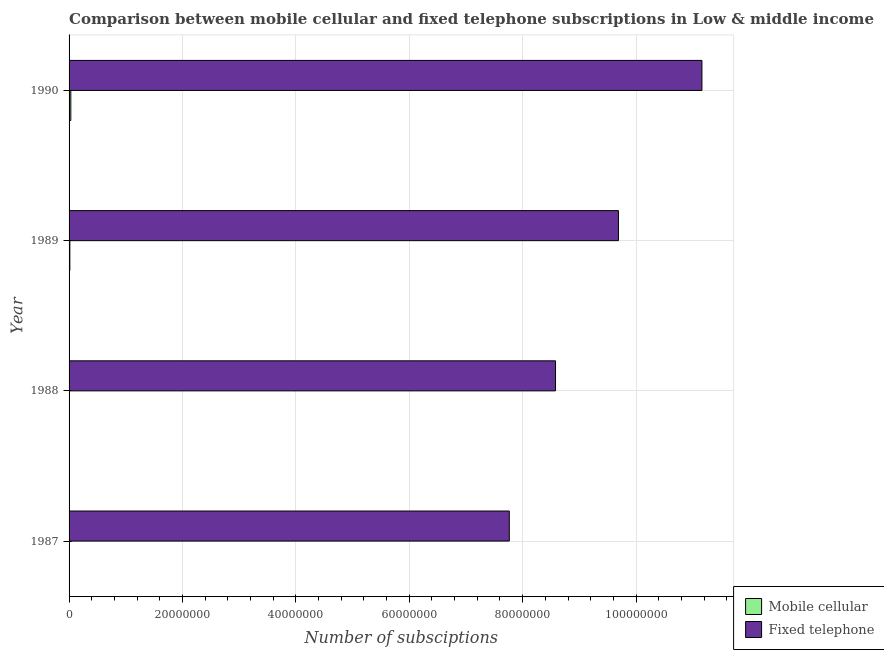How many different coloured bars are there?
Your response must be concise. 2. Are the number of bars per tick equal to the number of legend labels?
Keep it short and to the point. Yes. How many bars are there on the 4th tick from the top?
Keep it short and to the point. 2. In how many cases, is the number of bars for a given year not equal to the number of legend labels?
Provide a short and direct response. 0. What is the number of fixed telephone subscriptions in 1988?
Ensure brevity in your answer.  8.58e+07. Across all years, what is the maximum number of mobile cellular subscriptions?
Provide a short and direct response. 3.07e+05. Across all years, what is the minimum number of mobile cellular subscriptions?
Ensure brevity in your answer.  3.83e+04. In which year was the number of mobile cellular subscriptions maximum?
Provide a short and direct response. 1990. What is the total number of mobile cellular subscriptions in the graph?
Offer a very short reply. 5.52e+05. What is the difference between the number of fixed telephone subscriptions in 1987 and that in 1990?
Give a very brief answer. -3.40e+07. What is the difference between the number of fixed telephone subscriptions in 1987 and the number of mobile cellular subscriptions in 1988?
Give a very brief answer. 7.76e+07. What is the average number of mobile cellular subscriptions per year?
Give a very brief answer. 1.38e+05. In the year 1987, what is the difference between the number of fixed telephone subscriptions and number of mobile cellular subscriptions?
Ensure brevity in your answer.  7.76e+07. What is the ratio of the number of mobile cellular subscriptions in 1987 to that in 1989?
Provide a succinct answer. 0.28. What is the difference between the highest and the second highest number of fixed telephone subscriptions?
Make the answer very short. 1.47e+07. What is the difference between the highest and the lowest number of fixed telephone subscriptions?
Give a very brief answer. 3.40e+07. What does the 2nd bar from the top in 1988 represents?
Keep it short and to the point. Mobile cellular. What does the 1st bar from the bottom in 1987 represents?
Offer a terse response. Mobile cellular. Are the values on the major ticks of X-axis written in scientific E-notation?
Make the answer very short. No. Does the graph contain any zero values?
Provide a short and direct response. No. What is the title of the graph?
Offer a very short reply. Comparison between mobile cellular and fixed telephone subscriptions in Low & middle income. Does "constant 2005 US$" appear as one of the legend labels in the graph?
Provide a succinct answer. No. What is the label or title of the X-axis?
Your answer should be compact. Number of subsciptions. What is the Number of subsciptions in Mobile cellular in 1987?
Your answer should be very brief. 3.83e+04. What is the Number of subsciptions of Fixed telephone in 1987?
Offer a terse response. 7.76e+07. What is the Number of subsciptions of Mobile cellular in 1988?
Offer a very short reply. 7.20e+04. What is the Number of subsciptions of Fixed telephone in 1988?
Keep it short and to the point. 8.58e+07. What is the Number of subsciptions of Mobile cellular in 1989?
Your response must be concise. 1.35e+05. What is the Number of subsciptions in Fixed telephone in 1989?
Ensure brevity in your answer.  9.69e+07. What is the Number of subsciptions of Mobile cellular in 1990?
Ensure brevity in your answer.  3.07e+05. What is the Number of subsciptions in Fixed telephone in 1990?
Keep it short and to the point. 1.12e+08. Across all years, what is the maximum Number of subsciptions in Mobile cellular?
Your answer should be very brief. 3.07e+05. Across all years, what is the maximum Number of subsciptions in Fixed telephone?
Keep it short and to the point. 1.12e+08. Across all years, what is the minimum Number of subsciptions in Mobile cellular?
Give a very brief answer. 3.83e+04. Across all years, what is the minimum Number of subsciptions in Fixed telephone?
Ensure brevity in your answer.  7.76e+07. What is the total Number of subsciptions in Mobile cellular in the graph?
Your answer should be very brief. 5.52e+05. What is the total Number of subsciptions of Fixed telephone in the graph?
Offer a very short reply. 3.72e+08. What is the difference between the Number of subsciptions in Mobile cellular in 1987 and that in 1988?
Make the answer very short. -3.36e+04. What is the difference between the Number of subsciptions of Fixed telephone in 1987 and that in 1988?
Offer a terse response. -8.15e+06. What is the difference between the Number of subsciptions of Mobile cellular in 1987 and that in 1989?
Provide a succinct answer. -9.68e+04. What is the difference between the Number of subsciptions in Fixed telephone in 1987 and that in 1989?
Provide a succinct answer. -1.92e+07. What is the difference between the Number of subsciptions of Mobile cellular in 1987 and that in 1990?
Make the answer very short. -2.68e+05. What is the difference between the Number of subsciptions of Fixed telephone in 1987 and that in 1990?
Your answer should be very brief. -3.40e+07. What is the difference between the Number of subsciptions of Mobile cellular in 1988 and that in 1989?
Provide a succinct answer. -6.32e+04. What is the difference between the Number of subsciptions of Fixed telephone in 1988 and that in 1989?
Your answer should be compact. -1.11e+07. What is the difference between the Number of subsciptions in Mobile cellular in 1988 and that in 1990?
Provide a succinct answer. -2.35e+05. What is the difference between the Number of subsciptions in Fixed telephone in 1988 and that in 1990?
Keep it short and to the point. -2.58e+07. What is the difference between the Number of subsciptions in Mobile cellular in 1989 and that in 1990?
Provide a succinct answer. -1.71e+05. What is the difference between the Number of subsciptions in Fixed telephone in 1989 and that in 1990?
Your response must be concise. -1.47e+07. What is the difference between the Number of subsciptions of Mobile cellular in 1987 and the Number of subsciptions of Fixed telephone in 1988?
Provide a succinct answer. -8.58e+07. What is the difference between the Number of subsciptions of Mobile cellular in 1987 and the Number of subsciptions of Fixed telephone in 1989?
Give a very brief answer. -9.69e+07. What is the difference between the Number of subsciptions of Mobile cellular in 1987 and the Number of subsciptions of Fixed telephone in 1990?
Your answer should be very brief. -1.12e+08. What is the difference between the Number of subsciptions in Mobile cellular in 1988 and the Number of subsciptions in Fixed telephone in 1989?
Make the answer very short. -9.68e+07. What is the difference between the Number of subsciptions of Mobile cellular in 1988 and the Number of subsciptions of Fixed telephone in 1990?
Offer a terse response. -1.12e+08. What is the difference between the Number of subsciptions in Mobile cellular in 1989 and the Number of subsciptions in Fixed telephone in 1990?
Provide a short and direct response. -1.11e+08. What is the average Number of subsciptions of Mobile cellular per year?
Keep it short and to the point. 1.38e+05. What is the average Number of subsciptions in Fixed telephone per year?
Offer a very short reply. 9.30e+07. In the year 1987, what is the difference between the Number of subsciptions in Mobile cellular and Number of subsciptions in Fixed telephone?
Make the answer very short. -7.76e+07. In the year 1988, what is the difference between the Number of subsciptions of Mobile cellular and Number of subsciptions of Fixed telephone?
Keep it short and to the point. -8.57e+07. In the year 1989, what is the difference between the Number of subsciptions of Mobile cellular and Number of subsciptions of Fixed telephone?
Your response must be concise. -9.68e+07. In the year 1990, what is the difference between the Number of subsciptions in Mobile cellular and Number of subsciptions in Fixed telephone?
Provide a succinct answer. -1.11e+08. What is the ratio of the Number of subsciptions in Mobile cellular in 1987 to that in 1988?
Give a very brief answer. 0.53. What is the ratio of the Number of subsciptions of Fixed telephone in 1987 to that in 1988?
Make the answer very short. 0.91. What is the ratio of the Number of subsciptions of Mobile cellular in 1987 to that in 1989?
Offer a very short reply. 0.28. What is the ratio of the Number of subsciptions of Fixed telephone in 1987 to that in 1989?
Offer a very short reply. 0.8. What is the ratio of the Number of subsciptions in Fixed telephone in 1987 to that in 1990?
Offer a very short reply. 0.7. What is the ratio of the Number of subsciptions in Mobile cellular in 1988 to that in 1989?
Your response must be concise. 0.53. What is the ratio of the Number of subsciptions in Fixed telephone in 1988 to that in 1989?
Give a very brief answer. 0.89. What is the ratio of the Number of subsciptions in Mobile cellular in 1988 to that in 1990?
Your answer should be compact. 0.23. What is the ratio of the Number of subsciptions in Fixed telephone in 1988 to that in 1990?
Offer a very short reply. 0.77. What is the ratio of the Number of subsciptions in Mobile cellular in 1989 to that in 1990?
Provide a short and direct response. 0.44. What is the ratio of the Number of subsciptions in Fixed telephone in 1989 to that in 1990?
Ensure brevity in your answer.  0.87. What is the difference between the highest and the second highest Number of subsciptions in Mobile cellular?
Make the answer very short. 1.71e+05. What is the difference between the highest and the second highest Number of subsciptions of Fixed telephone?
Offer a very short reply. 1.47e+07. What is the difference between the highest and the lowest Number of subsciptions of Mobile cellular?
Offer a terse response. 2.68e+05. What is the difference between the highest and the lowest Number of subsciptions of Fixed telephone?
Keep it short and to the point. 3.40e+07. 